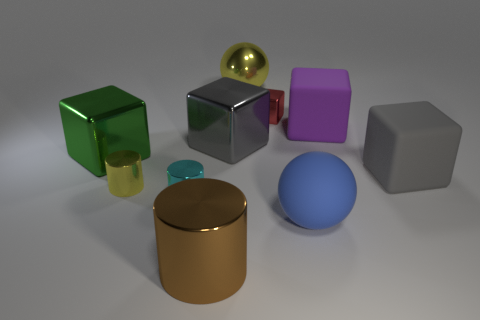What number of balls are either big blue objects or large yellow things?
Ensure brevity in your answer.  2. How many small shiny objects are both behind the tiny cyan metallic object and to the left of the brown thing?
Make the answer very short. 1. What number of other objects are there of the same color as the rubber sphere?
Your answer should be very brief. 0. There is a big matte thing to the left of the big purple matte block; what shape is it?
Provide a short and direct response. Sphere. Is the material of the brown cylinder the same as the yellow ball?
Keep it short and to the point. Yes. Is there anything else that is the same size as the yellow ball?
Ensure brevity in your answer.  Yes. There is a big purple rubber block; how many green things are behind it?
Make the answer very short. 0. There is a big metallic thing that is right of the gray thing that is on the left side of the big blue rubber thing; what is its shape?
Provide a succinct answer. Sphere. Is there anything else that has the same shape as the big yellow metallic object?
Offer a terse response. Yes. Is the number of metal cylinders that are behind the small red shiny block greater than the number of cyan things?
Your response must be concise. No. 